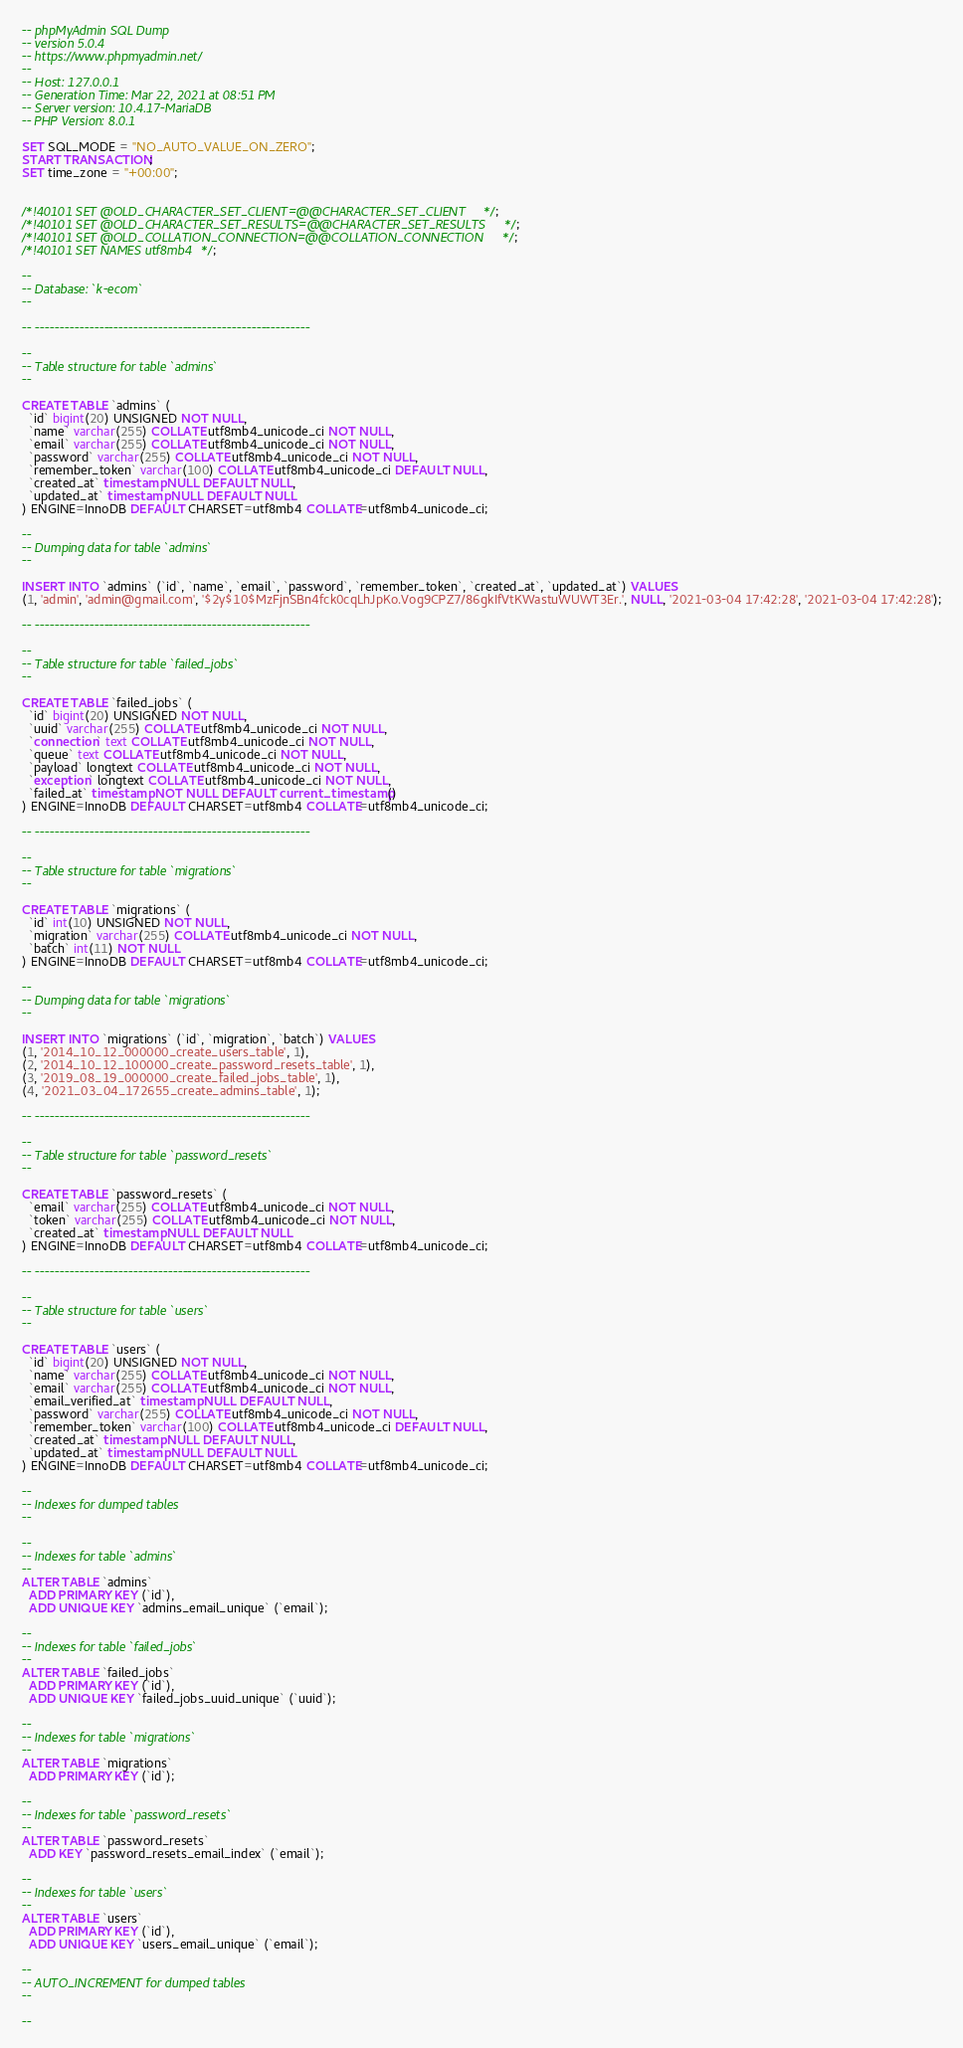Convert code to text. <code><loc_0><loc_0><loc_500><loc_500><_SQL_>-- phpMyAdmin SQL Dump
-- version 5.0.4
-- https://www.phpmyadmin.net/
--
-- Host: 127.0.0.1
-- Generation Time: Mar 22, 2021 at 08:51 PM
-- Server version: 10.4.17-MariaDB
-- PHP Version: 8.0.1

SET SQL_MODE = "NO_AUTO_VALUE_ON_ZERO";
START TRANSACTION;
SET time_zone = "+00:00";


/*!40101 SET @OLD_CHARACTER_SET_CLIENT=@@CHARACTER_SET_CLIENT */;
/*!40101 SET @OLD_CHARACTER_SET_RESULTS=@@CHARACTER_SET_RESULTS */;
/*!40101 SET @OLD_COLLATION_CONNECTION=@@COLLATION_CONNECTION */;
/*!40101 SET NAMES utf8mb4 */;

--
-- Database: `k-ecom`
--

-- --------------------------------------------------------

--
-- Table structure for table `admins`
--

CREATE TABLE `admins` (
  `id` bigint(20) UNSIGNED NOT NULL,
  `name` varchar(255) COLLATE utf8mb4_unicode_ci NOT NULL,
  `email` varchar(255) COLLATE utf8mb4_unicode_ci NOT NULL,
  `password` varchar(255) COLLATE utf8mb4_unicode_ci NOT NULL,
  `remember_token` varchar(100) COLLATE utf8mb4_unicode_ci DEFAULT NULL,
  `created_at` timestamp NULL DEFAULT NULL,
  `updated_at` timestamp NULL DEFAULT NULL
) ENGINE=InnoDB DEFAULT CHARSET=utf8mb4 COLLATE=utf8mb4_unicode_ci;

--
-- Dumping data for table `admins`
--

INSERT INTO `admins` (`id`, `name`, `email`, `password`, `remember_token`, `created_at`, `updated_at`) VALUES
(1, 'admin', 'admin@gmail.com', '$2y$10$MzFjnSBn4fck0cqLhJpKo.Vog9CPZ7/86gkIfVtKWastuWUWT3Er.', NULL, '2021-03-04 17:42:28', '2021-03-04 17:42:28');

-- --------------------------------------------------------

--
-- Table structure for table `failed_jobs`
--

CREATE TABLE `failed_jobs` (
  `id` bigint(20) UNSIGNED NOT NULL,
  `uuid` varchar(255) COLLATE utf8mb4_unicode_ci NOT NULL,
  `connection` text COLLATE utf8mb4_unicode_ci NOT NULL,
  `queue` text COLLATE utf8mb4_unicode_ci NOT NULL,
  `payload` longtext COLLATE utf8mb4_unicode_ci NOT NULL,
  `exception` longtext COLLATE utf8mb4_unicode_ci NOT NULL,
  `failed_at` timestamp NOT NULL DEFAULT current_timestamp()
) ENGINE=InnoDB DEFAULT CHARSET=utf8mb4 COLLATE=utf8mb4_unicode_ci;

-- --------------------------------------------------------

--
-- Table structure for table `migrations`
--

CREATE TABLE `migrations` (
  `id` int(10) UNSIGNED NOT NULL,
  `migration` varchar(255) COLLATE utf8mb4_unicode_ci NOT NULL,
  `batch` int(11) NOT NULL
) ENGINE=InnoDB DEFAULT CHARSET=utf8mb4 COLLATE=utf8mb4_unicode_ci;

--
-- Dumping data for table `migrations`
--

INSERT INTO `migrations` (`id`, `migration`, `batch`) VALUES
(1, '2014_10_12_000000_create_users_table', 1),
(2, '2014_10_12_100000_create_password_resets_table', 1),
(3, '2019_08_19_000000_create_failed_jobs_table', 1),
(4, '2021_03_04_172655_create_admins_table', 1);

-- --------------------------------------------------------

--
-- Table structure for table `password_resets`
--

CREATE TABLE `password_resets` (
  `email` varchar(255) COLLATE utf8mb4_unicode_ci NOT NULL,
  `token` varchar(255) COLLATE utf8mb4_unicode_ci NOT NULL,
  `created_at` timestamp NULL DEFAULT NULL
) ENGINE=InnoDB DEFAULT CHARSET=utf8mb4 COLLATE=utf8mb4_unicode_ci;

-- --------------------------------------------------------

--
-- Table structure for table `users`
--

CREATE TABLE `users` (
  `id` bigint(20) UNSIGNED NOT NULL,
  `name` varchar(255) COLLATE utf8mb4_unicode_ci NOT NULL,
  `email` varchar(255) COLLATE utf8mb4_unicode_ci NOT NULL,
  `email_verified_at` timestamp NULL DEFAULT NULL,
  `password` varchar(255) COLLATE utf8mb4_unicode_ci NOT NULL,
  `remember_token` varchar(100) COLLATE utf8mb4_unicode_ci DEFAULT NULL,
  `created_at` timestamp NULL DEFAULT NULL,
  `updated_at` timestamp NULL DEFAULT NULL
) ENGINE=InnoDB DEFAULT CHARSET=utf8mb4 COLLATE=utf8mb4_unicode_ci;

--
-- Indexes for dumped tables
--

--
-- Indexes for table `admins`
--
ALTER TABLE `admins`
  ADD PRIMARY KEY (`id`),
  ADD UNIQUE KEY `admins_email_unique` (`email`);

--
-- Indexes for table `failed_jobs`
--
ALTER TABLE `failed_jobs`
  ADD PRIMARY KEY (`id`),
  ADD UNIQUE KEY `failed_jobs_uuid_unique` (`uuid`);

--
-- Indexes for table `migrations`
--
ALTER TABLE `migrations`
  ADD PRIMARY KEY (`id`);

--
-- Indexes for table `password_resets`
--
ALTER TABLE `password_resets`
  ADD KEY `password_resets_email_index` (`email`);

--
-- Indexes for table `users`
--
ALTER TABLE `users`
  ADD PRIMARY KEY (`id`),
  ADD UNIQUE KEY `users_email_unique` (`email`);

--
-- AUTO_INCREMENT for dumped tables
--

--</code> 